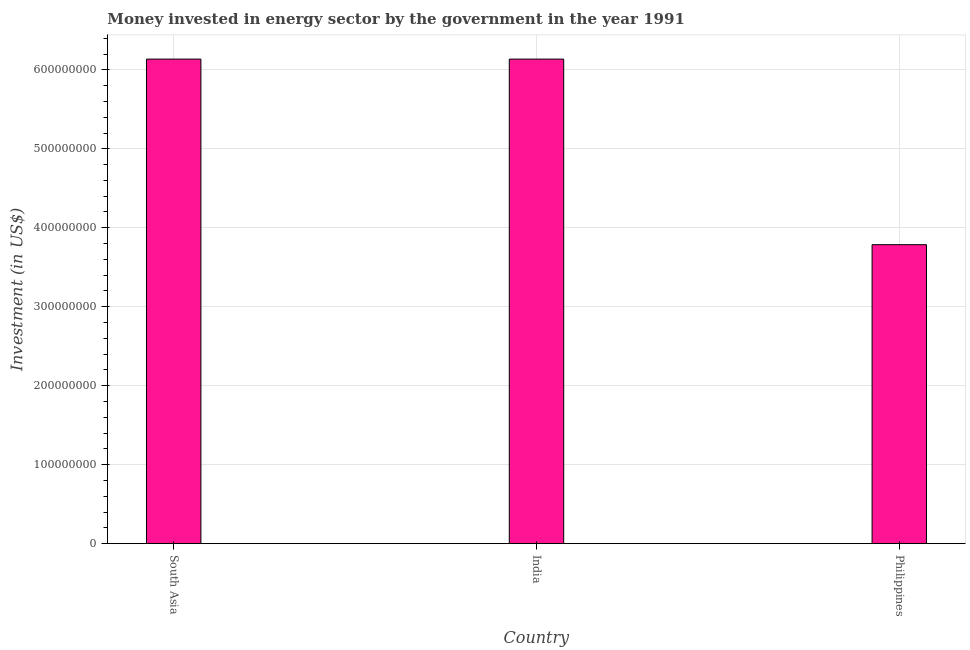Does the graph contain grids?
Offer a very short reply. Yes. What is the title of the graph?
Your response must be concise. Money invested in energy sector by the government in the year 1991. What is the label or title of the X-axis?
Ensure brevity in your answer.  Country. What is the label or title of the Y-axis?
Your answer should be compact. Investment (in US$). What is the investment in energy in India?
Your answer should be very brief. 6.14e+08. Across all countries, what is the maximum investment in energy?
Provide a succinct answer. 6.14e+08. Across all countries, what is the minimum investment in energy?
Provide a short and direct response. 3.79e+08. What is the sum of the investment in energy?
Offer a terse response. 1.61e+09. What is the difference between the investment in energy in Philippines and South Asia?
Give a very brief answer. -2.35e+08. What is the average investment in energy per country?
Your answer should be compact. 5.35e+08. What is the median investment in energy?
Your response must be concise. 6.14e+08. Is the investment in energy in India less than that in Philippines?
Offer a terse response. No. Is the difference between the investment in energy in India and South Asia greater than the difference between any two countries?
Provide a short and direct response. No. What is the difference between the highest and the second highest investment in energy?
Offer a terse response. 0. What is the difference between the highest and the lowest investment in energy?
Provide a short and direct response. 2.35e+08. How many bars are there?
Offer a very short reply. 3. What is the Investment (in US$) in South Asia?
Offer a terse response. 6.14e+08. What is the Investment (in US$) of India?
Offer a terse response. 6.14e+08. What is the Investment (in US$) of Philippines?
Provide a succinct answer. 3.79e+08. What is the difference between the Investment (in US$) in South Asia and Philippines?
Ensure brevity in your answer.  2.35e+08. What is the difference between the Investment (in US$) in India and Philippines?
Provide a short and direct response. 2.35e+08. What is the ratio of the Investment (in US$) in South Asia to that in Philippines?
Keep it short and to the point. 1.62. What is the ratio of the Investment (in US$) in India to that in Philippines?
Keep it short and to the point. 1.62. 